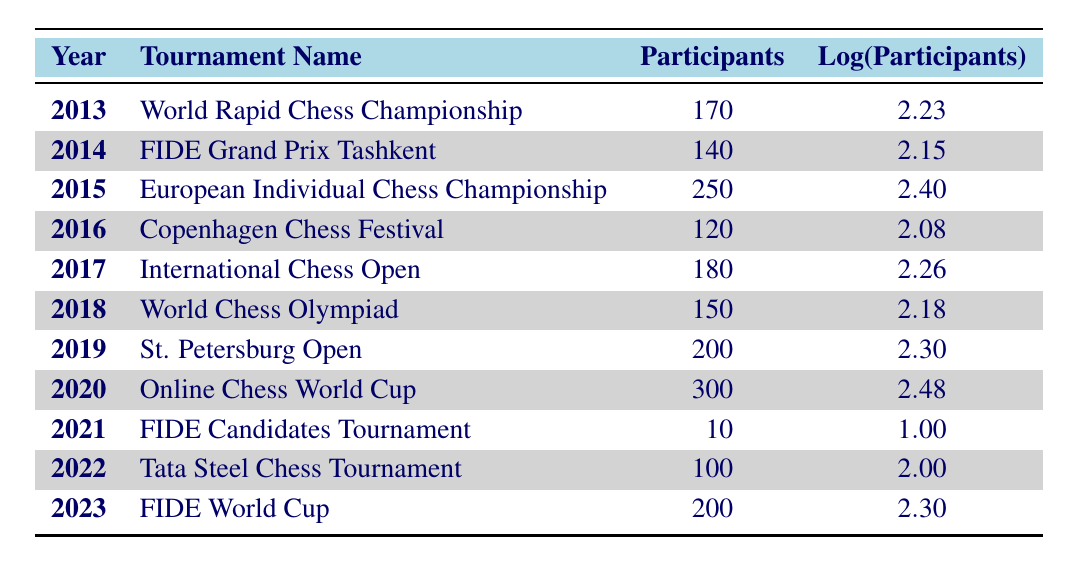What was the highest number of participants in a single tournament during the last decade? The table shows that the highest number of participants was 300 in the Online Chess World Cup in 2020.
Answer: 300 In which year did the FIDE Candidates Tournament have the least number of participants? By checking the participant numbers, the FIDE Candidates Tournament in 2021 had the least with only 10 participants.
Answer: 2021 What is the average number of participants across all tournaments in the last decade? To find the average, sum all participants (170 + 140 + 250 + 120 + 180 + 150 + 200 + 300 + 10 + 100 + 200 = 1820) and divide by the number of tournaments (11). The average is 1820/11 ≈ 165.45.
Answer: 165.45 Did the number of participants increase from 2019 to 2020? Comparing the two years, 2019 had 200 participants and 2020 had 300, so yes, there was an increase of 100 participants.
Answer: Yes Which tournament had a logarithmic value (Log(Participants)) greater than 2.4? Reviewing the Log(Participants) column, the only tournament with Log(Participants) greater than 2.4 is the Online Chess World Cup in 2020 with a value of 2.48.
Answer: Online Chess World Cup What are the total number of participants from 2016 to 2018? By adding the participants from those years (120 + 180 + 150 = 450), the total number of participants is 450.
Answer: 450 Did the number of participants in the Tata Steel Chess Tournament match or exceed the previous year's (2021)? The Tata Steel Chess Tournament in 2022 had 100 participants, while the FIDE Candidates Tournament in 2021 had only 10 participants, thus it exceeded it.
Answer: Yes What is the difference in the number of participants between the highest and lowest years? The highest number of participants is 300 in 2020 and the lowest is 10 in 2021. The difference is 300 - 10 = 290.
Answer: 290 Which tournament had the same number of participants as the International Chess Open? The International Chess Open and the World Rapid Chess Championship both had 180 participants.
Answer: World Rapid Chess Championship 